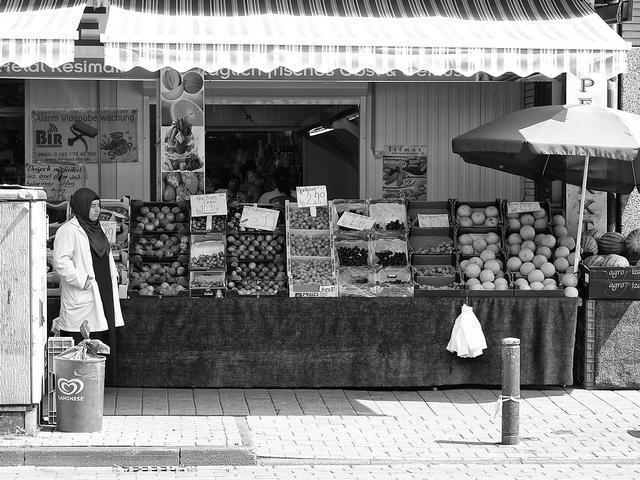The largest fruit shown here is what type of Fruit?
Make your selection and explain in format: 'Answer: answer
Rationale: rationale.'
Options: Cherry, citrus, pome, melon. Answer: melon.
Rationale: There are watermelons on the right. 